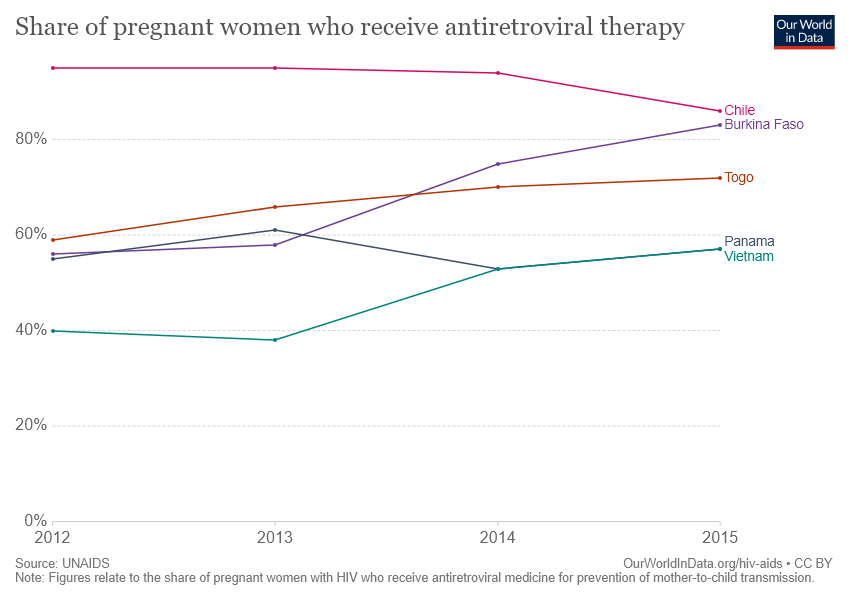Mention a couple of crucial points in this snapshot. Five countries are depicted in the chart. The gap between the topmost and lowest lines of a stacked bar chart reaches its peak when? The answer to this question is: in 2013. 